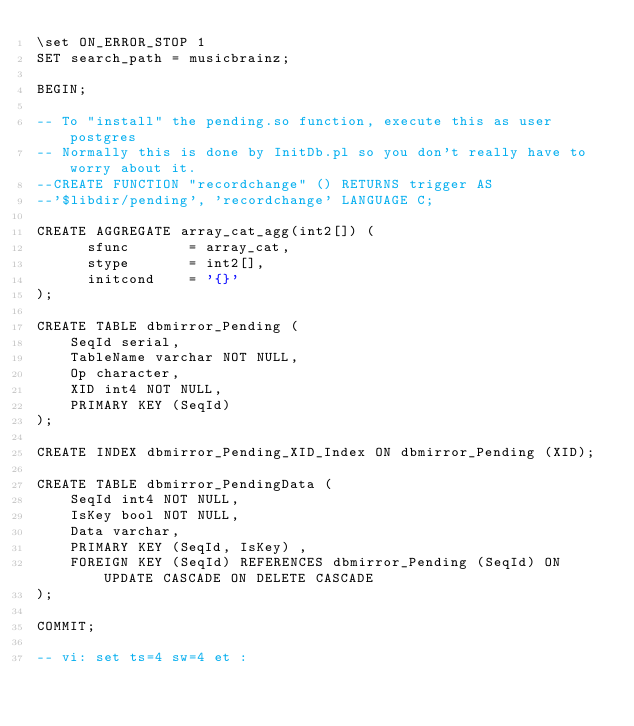<code> <loc_0><loc_0><loc_500><loc_500><_SQL_>\set ON_ERROR_STOP 1
SET search_path = musicbrainz;

BEGIN;

-- To "install" the pending.so function, execute this as user postgres
-- Normally this is done by InitDb.pl so you don't really have to worry about it.
--CREATE FUNCTION "recordchange" () RETURNS trigger AS
--'$libdir/pending', 'recordchange' LANGUAGE C;

CREATE AGGREGATE array_cat_agg(int2[]) (
      sfunc       = array_cat,
      stype       = int2[],
      initcond    = '{}'
);

CREATE TABLE dbmirror_Pending (
    SeqId serial,
    TableName varchar NOT NULL,
    Op character,
    XID int4 NOT NULL,
    PRIMARY KEY (SeqId)
);

CREATE INDEX dbmirror_Pending_XID_Index ON dbmirror_Pending (XID);

CREATE TABLE dbmirror_PendingData (
    SeqId int4 NOT NULL,
    IsKey bool NOT NULL,
    Data varchar,
    PRIMARY KEY (SeqId, IsKey) ,
    FOREIGN KEY (SeqId) REFERENCES dbmirror_Pending (SeqId) ON UPDATE CASCADE ON DELETE CASCADE
);

COMMIT;

-- vi: set ts=4 sw=4 et :
</code> 